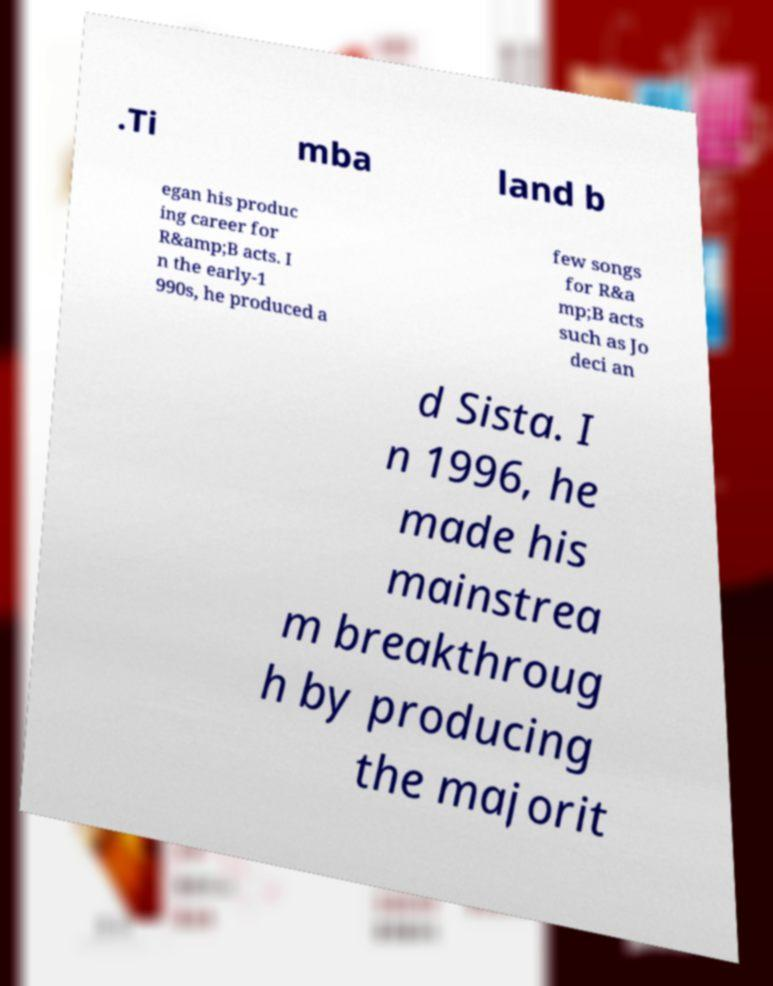Could you assist in decoding the text presented in this image and type it out clearly? .Ti mba land b egan his produc ing career for R&amp;B acts. I n the early-1 990s, he produced a few songs for R&a mp;B acts such as Jo deci an d Sista. I n 1996, he made his mainstrea m breakthroug h by producing the majorit 